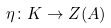<formula> <loc_0><loc_0><loc_500><loc_500>\eta \colon K \to Z ( A )</formula> 